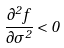<formula> <loc_0><loc_0><loc_500><loc_500>\frac { \partial ^ { 2 } f } { \partial \sigma ^ { 2 } } < 0</formula> 